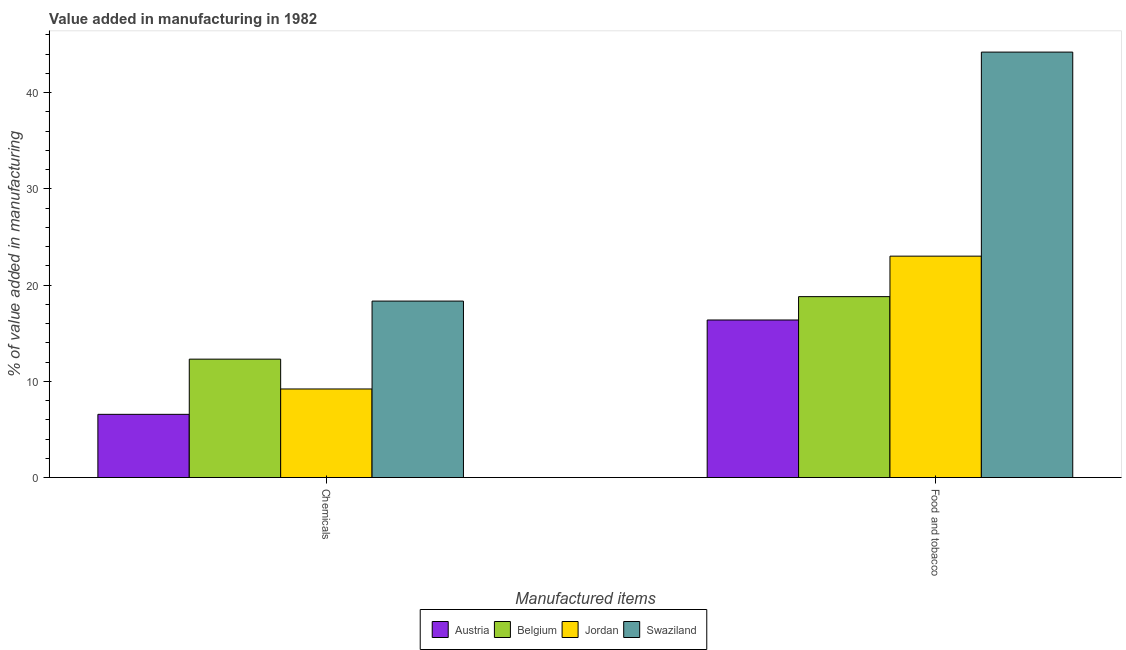How many different coloured bars are there?
Give a very brief answer. 4. Are the number of bars per tick equal to the number of legend labels?
Provide a short and direct response. Yes. Are the number of bars on each tick of the X-axis equal?
Offer a very short reply. Yes. How many bars are there on the 1st tick from the right?
Provide a short and direct response. 4. What is the label of the 1st group of bars from the left?
Give a very brief answer. Chemicals. What is the value added by manufacturing food and tobacco in Jordan?
Keep it short and to the point. 23. Across all countries, what is the maximum value added by  manufacturing chemicals?
Provide a short and direct response. 18.33. Across all countries, what is the minimum value added by manufacturing food and tobacco?
Your response must be concise. 16.37. In which country was the value added by manufacturing food and tobacco maximum?
Keep it short and to the point. Swaziland. What is the total value added by  manufacturing chemicals in the graph?
Your answer should be compact. 46.4. What is the difference between the value added by  manufacturing chemicals in Belgium and that in Swaziland?
Your response must be concise. -6.03. What is the difference between the value added by manufacturing food and tobacco in Belgium and the value added by  manufacturing chemicals in Austria?
Keep it short and to the point. 12.23. What is the average value added by manufacturing food and tobacco per country?
Give a very brief answer. 25.59. What is the difference between the value added by  manufacturing chemicals and value added by manufacturing food and tobacco in Austria?
Offer a very short reply. -9.8. In how many countries, is the value added by  manufacturing chemicals greater than 4 %?
Your response must be concise. 4. What is the ratio of the value added by manufacturing food and tobacco in Austria to that in Belgium?
Your answer should be very brief. 0.87. In how many countries, is the value added by manufacturing food and tobacco greater than the average value added by manufacturing food and tobacco taken over all countries?
Keep it short and to the point. 1. What does the 4th bar from the right in Food and tobacco represents?
Your answer should be very brief. Austria. How many bars are there?
Provide a succinct answer. 8. Are all the bars in the graph horizontal?
Provide a short and direct response. No. How many countries are there in the graph?
Your response must be concise. 4. Are the values on the major ticks of Y-axis written in scientific E-notation?
Keep it short and to the point. No. Where does the legend appear in the graph?
Provide a short and direct response. Bottom center. How many legend labels are there?
Ensure brevity in your answer.  4. How are the legend labels stacked?
Keep it short and to the point. Horizontal. What is the title of the graph?
Ensure brevity in your answer.  Value added in manufacturing in 1982. Does "Greenland" appear as one of the legend labels in the graph?
Your response must be concise. No. What is the label or title of the X-axis?
Provide a short and direct response. Manufactured items. What is the label or title of the Y-axis?
Your response must be concise. % of value added in manufacturing. What is the % of value added in manufacturing in Austria in Chemicals?
Keep it short and to the point. 6.57. What is the % of value added in manufacturing in Belgium in Chemicals?
Provide a succinct answer. 12.3. What is the % of value added in manufacturing in Jordan in Chemicals?
Make the answer very short. 9.2. What is the % of value added in manufacturing in Swaziland in Chemicals?
Make the answer very short. 18.33. What is the % of value added in manufacturing of Austria in Food and tobacco?
Your answer should be compact. 16.37. What is the % of value added in manufacturing in Belgium in Food and tobacco?
Your answer should be compact. 18.8. What is the % of value added in manufacturing of Jordan in Food and tobacco?
Your response must be concise. 23. What is the % of value added in manufacturing in Swaziland in Food and tobacco?
Give a very brief answer. 44.2. Across all Manufactured items, what is the maximum % of value added in manufacturing in Austria?
Give a very brief answer. 16.37. Across all Manufactured items, what is the maximum % of value added in manufacturing of Belgium?
Offer a very short reply. 18.8. Across all Manufactured items, what is the maximum % of value added in manufacturing of Jordan?
Your answer should be compact. 23. Across all Manufactured items, what is the maximum % of value added in manufacturing of Swaziland?
Make the answer very short. 44.2. Across all Manufactured items, what is the minimum % of value added in manufacturing of Austria?
Your answer should be very brief. 6.57. Across all Manufactured items, what is the minimum % of value added in manufacturing of Belgium?
Offer a terse response. 12.3. Across all Manufactured items, what is the minimum % of value added in manufacturing of Jordan?
Give a very brief answer. 9.2. Across all Manufactured items, what is the minimum % of value added in manufacturing of Swaziland?
Ensure brevity in your answer.  18.33. What is the total % of value added in manufacturing in Austria in the graph?
Make the answer very short. 22.94. What is the total % of value added in manufacturing of Belgium in the graph?
Offer a terse response. 31.1. What is the total % of value added in manufacturing of Jordan in the graph?
Provide a short and direct response. 32.2. What is the total % of value added in manufacturing of Swaziland in the graph?
Your response must be concise. 62.53. What is the difference between the % of value added in manufacturing in Austria in Chemicals and that in Food and tobacco?
Your answer should be very brief. -9.8. What is the difference between the % of value added in manufacturing of Belgium in Chemicals and that in Food and tobacco?
Provide a succinct answer. -6.49. What is the difference between the % of value added in manufacturing in Jordan in Chemicals and that in Food and tobacco?
Your response must be concise. -13.8. What is the difference between the % of value added in manufacturing of Swaziland in Chemicals and that in Food and tobacco?
Ensure brevity in your answer.  -25.87. What is the difference between the % of value added in manufacturing in Austria in Chemicals and the % of value added in manufacturing in Belgium in Food and tobacco?
Ensure brevity in your answer.  -12.23. What is the difference between the % of value added in manufacturing in Austria in Chemicals and the % of value added in manufacturing in Jordan in Food and tobacco?
Offer a terse response. -16.43. What is the difference between the % of value added in manufacturing in Austria in Chemicals and the % of value added in manufacturing in Swaziland in Food and tobacco?
Ensure brevity in your answer.  -37.63. What is the difference between the % of value added in manufacturing of Belgium in Chemicals and the % of value added in manufacturing of Jordan in Food and tobacco?
Keep it short and to the point. -10.7. What is the difference between the % of value added in manufacturing in Belgium in Chemicals and the % of value added in manufacturing in Swaziland in Food and tobacco?
Give a very brief answer. -31.9. What is the difference between the % of value added in manufacturing of Jordan in Chemicals and the % of value added in manufacturing of Swaziland in Food and tobacco?
Offer a very short reply. -35. What is the average % of value added in manufacturing of Austria per Manufactured items?
Offer a terse response. 11.47. What is the average % of value added in manufacturing of Belgium per Manufactured items?
Offer a very short reply. 15.55. What is the average % of value added in manufacturing of Jordan per Manufactured items?
Give a very brief answer. 16.1. What is the average % of value added in manufacturing of Swaziland per Manufactured items?
Offer a very short reply. 31.27. What is the difference between the % of value added in manufacturing in Austria and % of value added in manufacturing in Belgium in Chemicals?
Give a very brief answer. -5.73. What is the difference between the % of value added in manufacturing in Austria and % of value added in manufacturing in Jordan in Chemicals?
Your response must be concise. -2.63. What is the difference between the % of value added in manufacturing of Austria and % of value added in manufacturing of Swaziland in Chemicals?
Your answer should be very brief. -11.77. What is the difference between the % of value added in manufacturing in Belgium and % of value added in manufacturing in Jordan in Chemicals?
Your answer should be compact. 3.1. What is the difference between the % of value added in manufacturing of Belgium and % of value added in manufacturing of Swaziland in Chemicals?
Make the answer very short. -6.03. What is the difference between the % of value added in manufacturing of Jordan and % of value added in manufacturing of Swaziland in Chemicals?
Your answer should be compact. -9.13. What is the difference between the % of value added in manufacturing in Austria and % of value added in manufacturing in Belgium in Food and tobacco?
Ensure brevity in your answer.  -2.43. What is the difference between the % of value added in manufacturing of Austria and % of value added in manufacturing of Jordan in Food and tobacco?
Ensure brevity in your answer.  -6.63. What is the difference between the % of value added in manufacturing of Austria and % of value added in manufacturing of Swaziland in Food and tobacco?
Make the answer very short. -27.83. What is the difference between the % of value added in manufacturing of Belgium and % of value added in manufacturing of Jordan in Food and tobacco?
Give a very brief answer. -4.21. What is the difference between the % of value added in manufacturing of Belgium and % of value added in manufacturing of Swaziland in Food and tobacco?
Your response must be concise. -25.4. What is the difference between the % of value added in manufacturing of Jordan and % of value added in manufacturing of Swaziland in Food and tobacco?
Your response must be concise. -21.2. What is the ratio of the % of value added in manufacturing of Austria in Chemicals to that in Food and tobacco?
Keep it short and to the point. 0.4. What is the ratio of the % of value added in manufacturing in Belgium in Chemicals to that in Food and tobacco?
Keep it short and to the point. 0.65. What is the ratio of the % of value added in manufacturing in Jordan in Chemicals to that in Food and tobacco?
Offer a terse response. 0.4. What is the ratio of the % of value added in manufacturing in Swaziland in Chemicals to that in Food and tobacco?
Ensure brevity in your answer.  0.41. What is the difference between the highest and the second highest % of value added in manufacturing of Austria?
Your answer should be compact. 9.8. What is the difference between the highest and the second highest % of value added in manufacturing of Belgium?
Ensure brevity in your answer.  6.49. What is the difference between the highest and the second highest % of value added in manufacturing of Jordan?
Provide a succinct answer. 13.8. What is the difference between the highest and the second highest % of value added in manufacturing of Swaziland?
Make the answer very short. 25.87. What is the difference between the highest and the lowest % of value added in manufacturing of Austria?
Provide a short and direct response. 9.8. What is the difference between the highest and the lowest % of value added in manufacturing in Belgium?
Make the answer very short. 6.49. What is the difference between the highest and the lowest % of value added in manufacturing of Jordan?
Your answer should be very brief. 13.8. What is the difference between the highest and the lowest % of value added in manufacturing of Swaziland?
Your answer should be very brief. 25.87. 